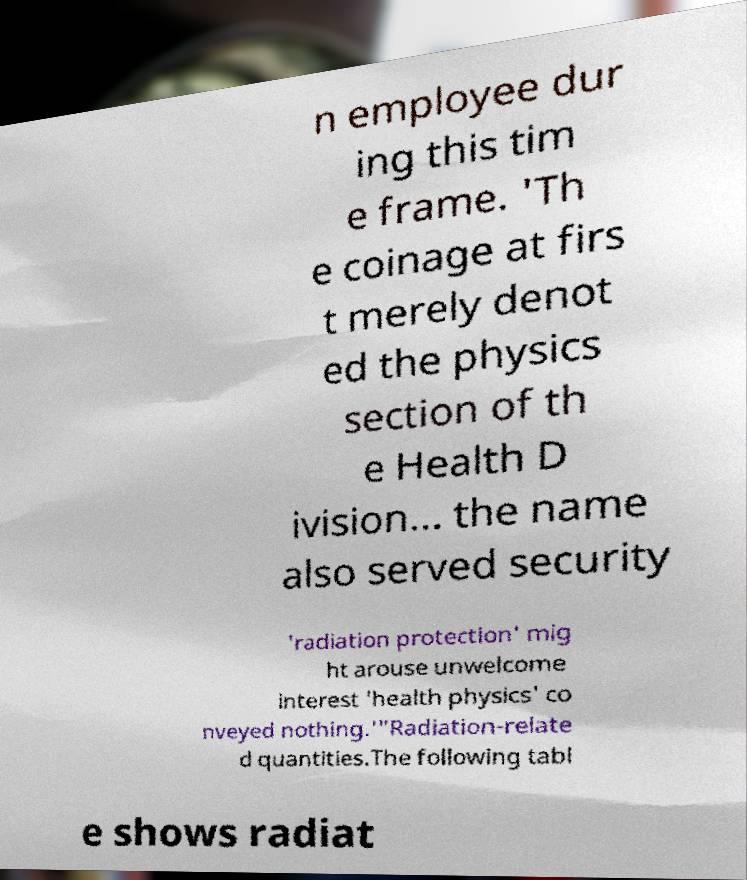Could you assist in decoding the text presented in this image and type it out clearly? n employee dur ing this tim e frame. 'Th e coinage at firs t merely denot ed the physics section of th e Health D ivision... the name also served security 'radiation protection' mig ht arouse unwelcome interest 'health physics' co nveyed nothing.'"Radiation-relate d quantities.The following tabl e shows radiat 